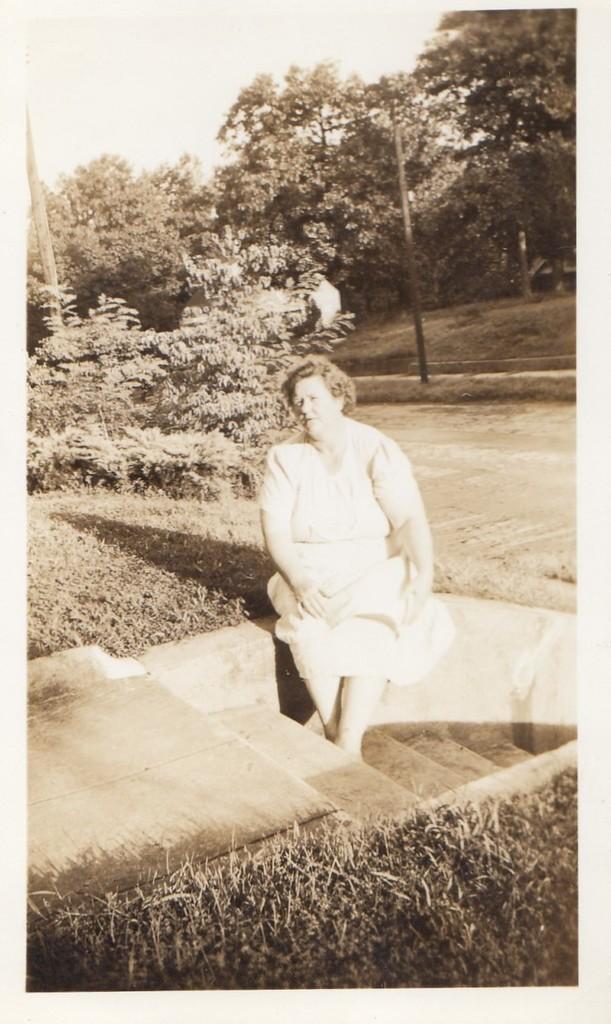Can you describe this image briefly? This image consists of a woman wearing white dress. At the bottom, there is grass. In the middle, there are steps. At the top, there is sky. In the background, there are trees. 